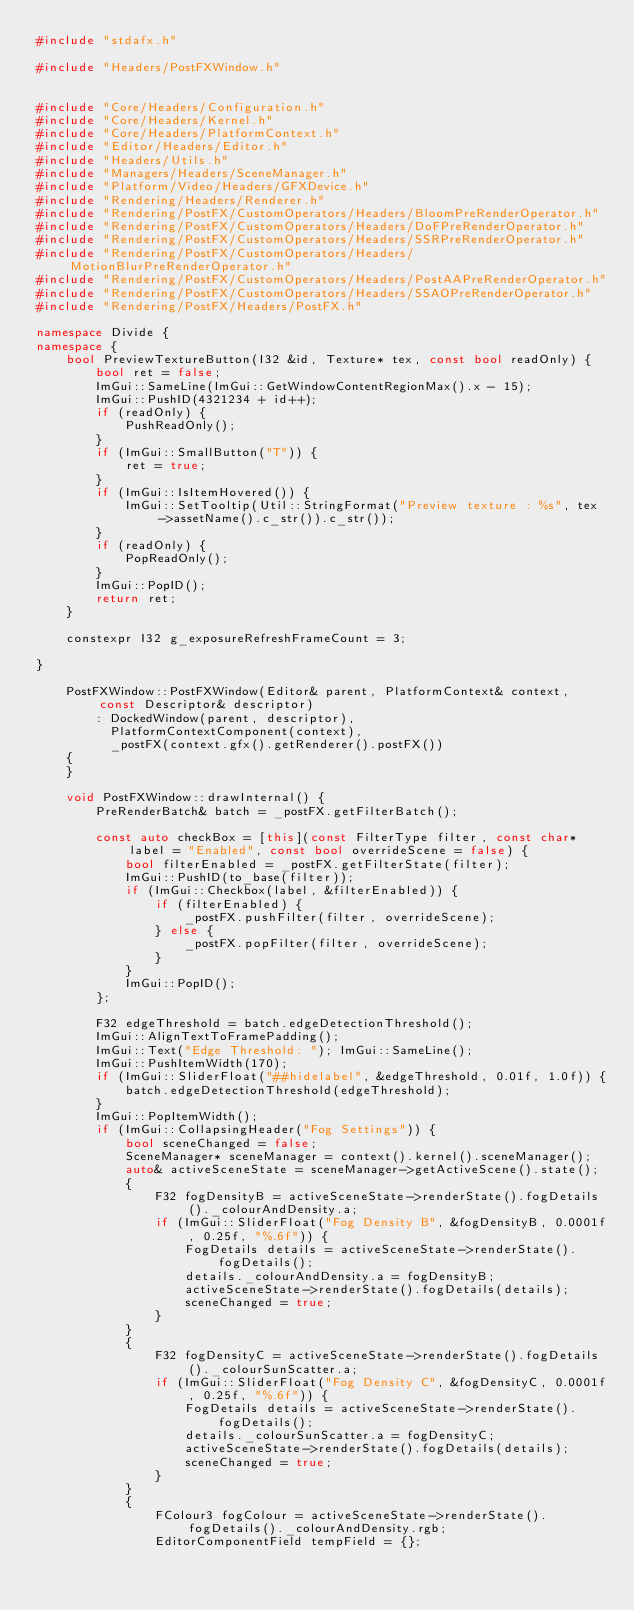Convert code to text. <code><loc_0><loc_0><loc_500><loc_500><_C++_>#include "stdafx.h"

#include "Headers/PostFXWindow.h"


#include "Core/Headers/Configuration.h"
#include "Core/Headers/Kernel.h"
#include "Core/Headers/PlatformContext.h"
#include "Editor/Headers/Editor.h"
#include "Headers/Utils.h"
#include "Managers/Headers/SceneManager.h"
#include "Platform/Video/Headers/GFXDevice.h"
#include "Rendering/Headers/Renderer.h"
#include "Rendering/PostFX/CustomOperators/Headers/BloomPreRenderOperator.h"
#include "Rendering/PostFX/CustomOperators/Headers/DoFPreRenderOperator.h"
#include "Rendering/PostFX/CustomOperators/Headers/SSRPreRenderOperator.h"
#include "Rendering/PostFX/CustomOperators/Headers/MotionBlurPreRenderOperator.h"
#include "Rendering/PostFX/CustomOperators/Headers/PostAAPreRenderOperator.h"
#include "Rendering/PostFX/CustomOperators/Headers/SSAOPreRenderOperator.h"
#include "Rendering/PostFX/Headers/PostFX.h"

namespace Divide {
namespace {
    bool PreviewTextureButton(I32 &id, Texture* tex, const bool readOnly) {
        bool ret = false;
        ImGui::SameLine(ImGui::GetWindowContentRegionMax().x - 15);
        ImGui::PushID(4321234 + id++);
        if (readOnly) {
            PushReadOnly();
        }
        if (ImGui::SmallButton("T")) {
            ret = true;
        }
        if (ImGui::IsItemHovered()) {
            ImGui::SetTooltip(Util::StringFormat("Preview texture : %s", tex->assetName().c_str()).c_str());
        }
        if (readOnly) {
            PopReadOnly();
        }
        ImGui::PopID();
        return ret;
    }

    constexpr I32 g_exposureRefreshFrameCount = 3;

}

    PostFXWindow::PostFXWindow(Editor& parent, PlatformContext& context, const Descriptor& descriptor)
        : DockedWindow(parent, descriptor),
          PlatformContextComponent(context),
          _postFX(context.gfx().getRenderer().postFX())
    {
    }

    void PostFXWindow::drawInternal() {
        PreRenderBatch& batch = _postFX.getFilterBatch();

        const auto checkBox = [this](const FilterType filter, const char* label = "Enabled", const bool overrideScene = false) {
            bool filterEnabled = _postFX.getFilterState(filter);
            ImGui::PushID(to_base(filter));
            if (ImGui::Checkbox(label, &filterEnabled)) {
                if (filterEnabled) {
                    _postFX.pushFilter(filter, overrideScene);
                } else {
                    _postFX.popFilter(filter, overrideScene);
                }
            }
            ImGui::PopID();
        };

        F32 edgeThreshold = batch.edgeDetectionThreshold();
        ImGui::AlignTextToFramePadding();
        ImGui::Text("Edge Threshold: "); ImGui::SameLine();
        ImGui::PushItemWidth(170);
        if (ImGui::SliderFloat("##hidelabel", &edgeThreshold, 0.01f, 1.0f)) {
            batch.edgeDetectionThreshold(edgeThreshold);
        }
        ImGui::PopItemWidth();
        if (ImGui::CollapsingHeader("Fog Settings")) {
            bool sceneChanged = false;
            SceneManager* sceneManager = context().kernel().sceneManager();
            auto& activeSceneState = sceneManager->getActiveScene().state();
            {
                F32 fogDensityB = activeSceneState->renderState().fogDetails()._colourAndDensity.a;
                if (ImGui::SliderFloat("Fog Density B", &fogDensityB, 0.0001f, 0.25f, "%.6f")) {
                    FogDetails details = activeSceneState->renderState().fogDetails();
                    details._colourAndDensity.a = fogDensityB;
                    activeSceneState->renderState().fogDetails(details);
                    sceneChanged = true;
                }
            }
            {
                F32 fogDensityC = activeSceneState->renderState().fogDetails()._colourSunScatter.a;
                if (ImGui::SliderFloat("Fog Density C", &fogDensityC, 0.0001f, 0.25f, "%.6f")) {
                    FogDetails details = activeSceneState->renderState().fogDetails();
                    details._colourSunScatter.a = fogDensityC;
                    activeSceneState->renderState().fogDetails(details);
                    sceneChanged = true;
                }
            }
            {
                FColour3 fogColour = activeSceneState->renderState().fogDetails()._colourAndDensity.rgb;
                EditorComponentField tempField = {};</code> 